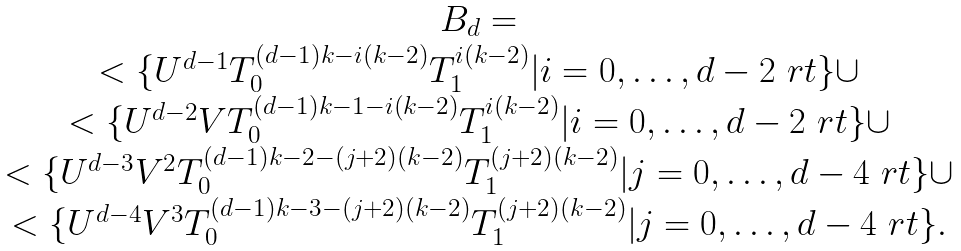Convert formula to latex. <formula><loc_0><loc_0><loc_500><loc_500>\begin{array} { c } B _ { d } = \\ < \{ U ^ { d - 1 } T _ { 0 } ^ { ( d - 1 ) k - i ( k - 2 ) } T _ { 1 } ^ { i ( k - 2 ) } | i = 0 , \dots , d - 2 \ r t \} \cup \\ < \{ U ^ { d - 2 } V T _ { 0 } ^ { ( d - 1 ) k - 1 - i ( k - 2 ) } T _ { 1 } ^ { i ( k - 2 ) } | i = 0 , \dots , d - 2 \ r t \} \cup \\ < \{ U ^ { d - 3 } V ^ { 2 } T _ { 0 } ^ { ( d - 1 ) k - 2 - ( j + 2 ) ( k - 2 ) } T _ { 1 } ^ { ( j + 2 ) ( k - 2 ) } | j = 0 , \dots , d - 4 \ r t \} \cup \\ < \{ U ^ { d - 4 } V ^ { 3 } T _ { 0 } ^ { ( d - 1 ) k - 3 - ( j + 2 ) ( k - 2 ) } T _ { 1 } ^ { ( j + 2 ) ( k - 2 ) } | j = 0 , \dots , d - 4 \ r t \} . \end{array}</formula> 